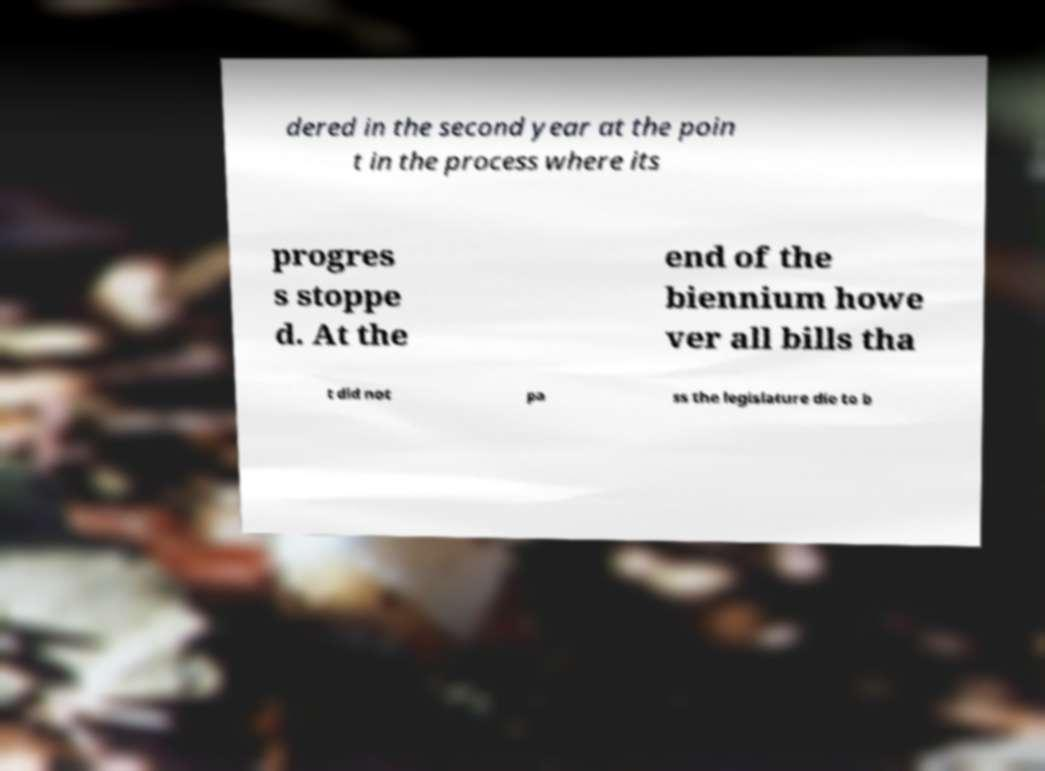Could you extract and type out the text from this image? dered in the second year at the poin t in the process where its progres s stoppe d. At the end of the biennium howe ver all bills tha t did not pa ss the legislature die to b 